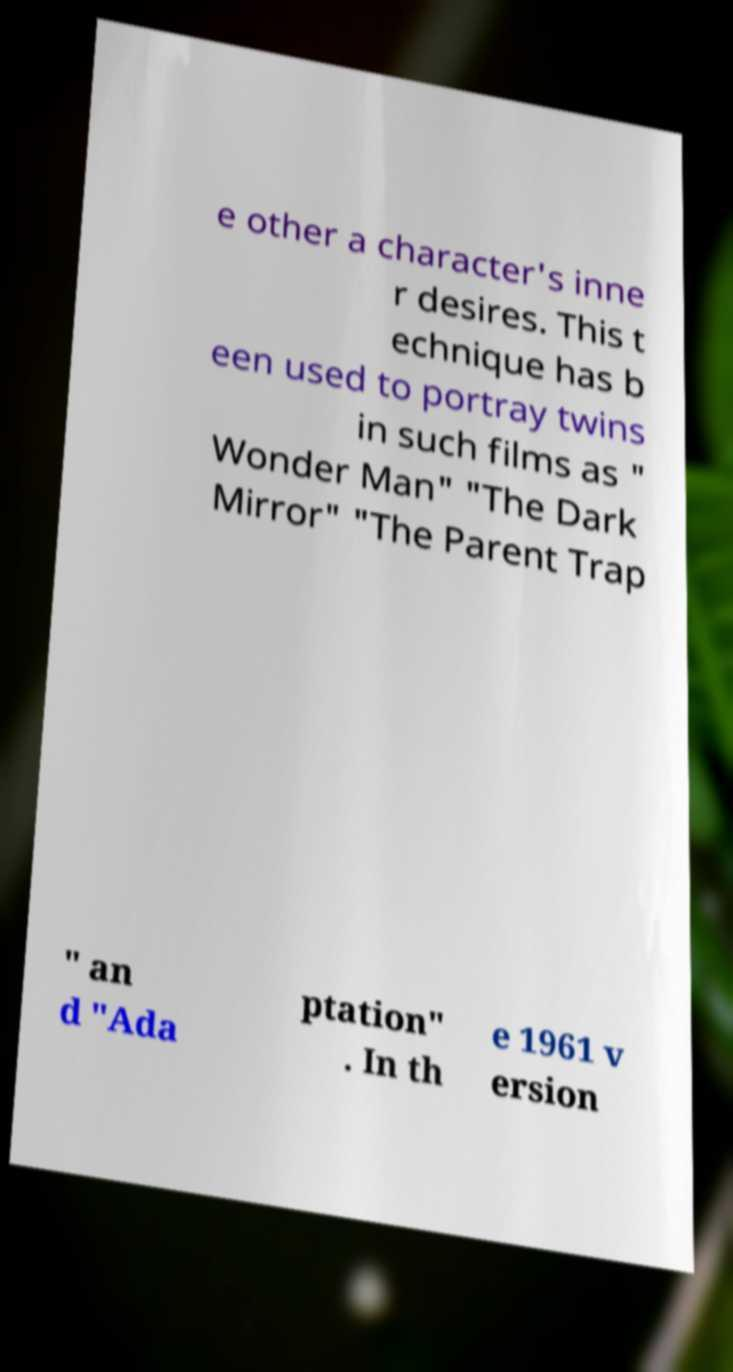Please read and relay the text visible in this image. What does it say? e other a character's inne r desires. This t echnique has b een used to portray twins in such films as " Wonder Man" "The Dark Mirror" "The Parent Trap " an d "Ada ptation" . In th e 1961 v ersion 